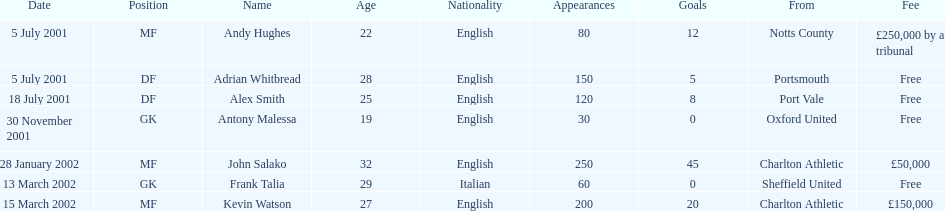Andy huges and adrian whitbread both tranfered on which date? 5 July 2001. 